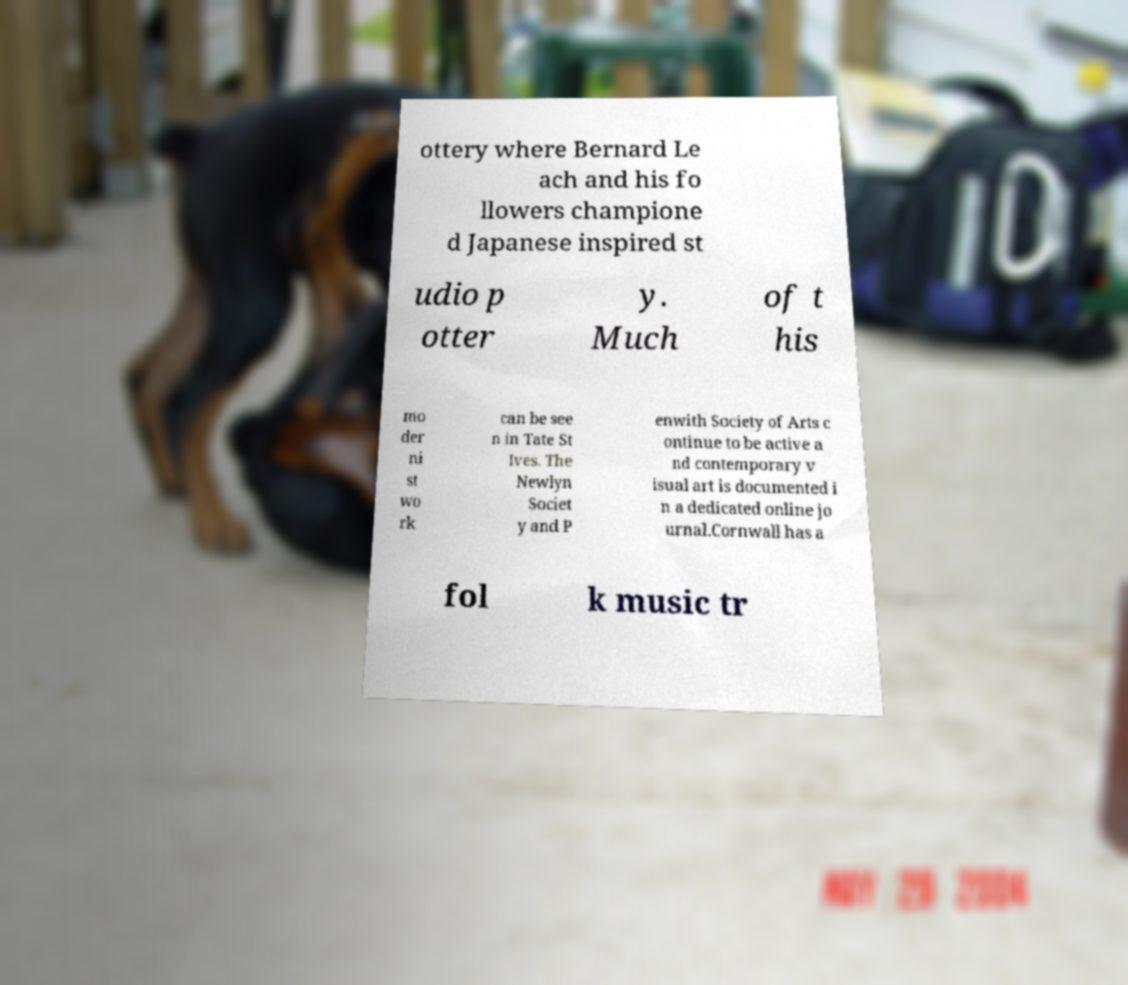There's text embedded in this image that I need extracted. Can you transcribe it verbatim? ottery where Bernard Le ach and his fo llowers champione d Japanese inspired st udio p otter y. Much of t his mo der ni st wo rk can be see n in Tate St Ives. The Newlyn Societ y and P enwith Society of Arts c ontinue to be active a nd contemporary v isual art is documented i n a dedicated online jo urnal.Cornwall has a fol k music tr 